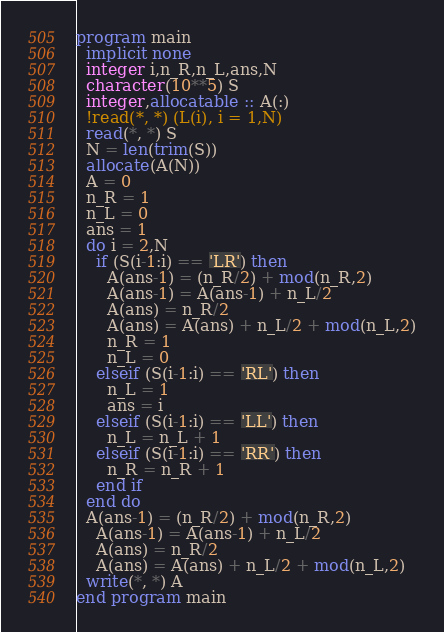Convert code to text. <code><loc_0><loc_0><loc_500><loc_500><_FORTRAN_>program main
  implicit none
  integer i,n_R,n_L,ans,N
  character(10**5) S
  integer,allocatable :: A(:)
  !read(*, *) (L(i), i = 1,N)
  read(*, *) S
  N = len(trim(S))
  allocate(A(N))
  A = 0
  n_R = 1
  n_L = 0
  ans = 1
  do i = 2,N
    if (S(i-1:i) == 'LR') then
      A(ans-1) = (n_R/2) + mod(n_R,2)
      A(ans-1) = A(ans-1) + n_L/2
      A(ans) = n_R/2
      A(ans) = A(ans) + n_L/2 + mod(n_L,2)
      n_R = 1
      n_L = 0
    elseif (S(i-1:i) == 'RL') then
      n_L = 1
      ans = i
    elseif (S(i-1:i) == 'LL') then
      n_L = n_L + 1
    elseif (S(i-1:i) == 'RR') then
      n_R = n_R + 1
    end if
  end do
  A(ans-1) = (n_R/2) + mod(n_R,2)
    A(ans-1) = A(ans-1) + n_L/2
    A(ans) = n_R/2
    A(ans) = A(ans) + n_L/2 + mod(n_L,2)
  write(*, *) A
end program main
</code> 